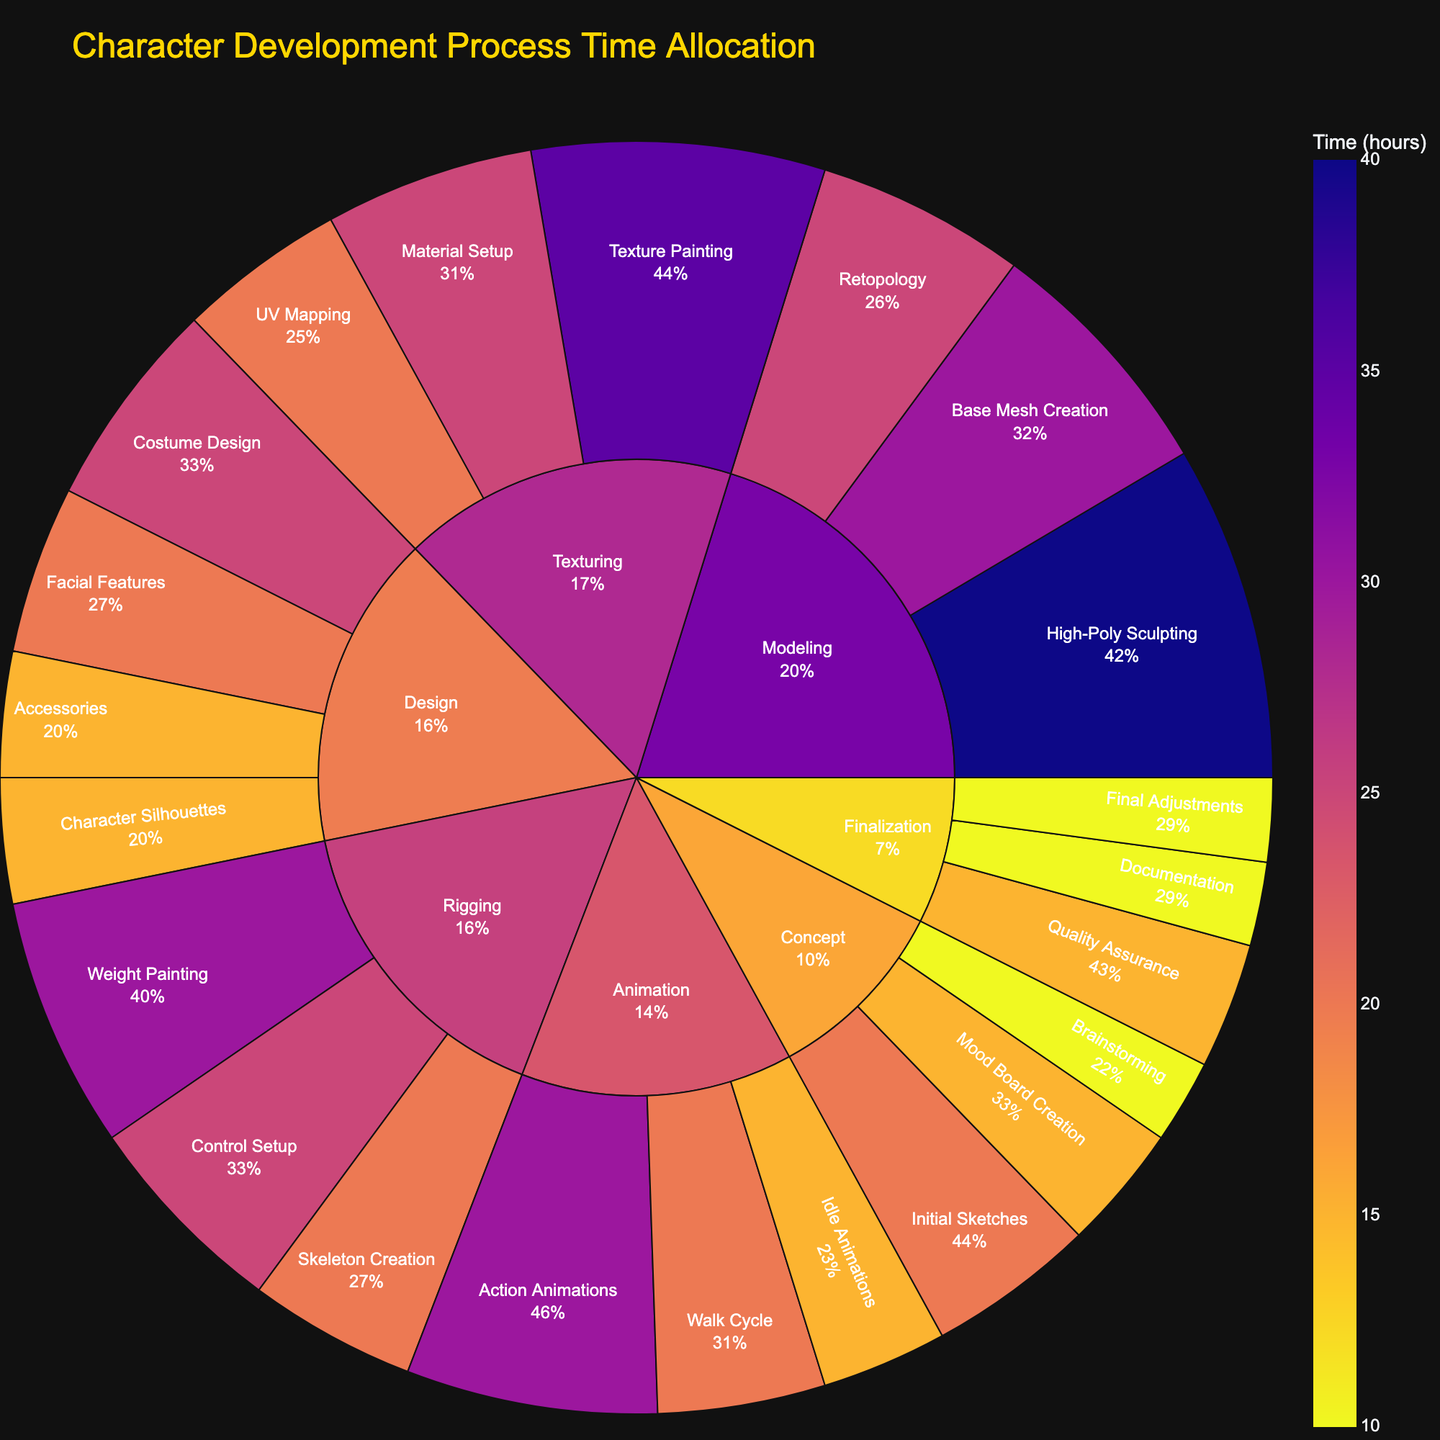What stage of the character development process takes the most time? To determine which stage takes the most time, we need to sum the time spent on each substage within each stage. The stage with the highest total time is the one that takes the most time. Summing the times, we get: Concept (45 hours), Design (75 hours), Modeling (95 hours), Texturing (80 hours), Rigging (75 hours), Animation (65 hours), Finalization (35 hours). Therefore, the stage that takes the most time is Modeling.
Answer: Modeling How much total time is spent on Animation and Finalization combined? To find the total time spent on Animation and Finalization, sum the time spent on each substage within these stages. For Animation: Walk Cycle (20 hours), Idle Animations (15 hours), Action Animations (30 hours), totaling 65 hours. For Finalization: Quality Assurance (15 hours), Final Adjustments (10 hours), Documentation (10 hours), totaling 35 hours. The combined total is 65 + 35 = 100 hours.
Answer: 100 hours Which substage under Design takes the least amount of time? To identify the substage under Design that takes the least time, we compare the time allocated to each substage: Character Silhouettes (15 hours), Facial Features (20 hours), Costume Design (25 hours), Accessories (15 hours). Both Character Silhouettes and Accessories take 15 hours, which is the least time.
Answer: Character Silhouettes and Accessories What percentage of the total time is spent on the Texturing stage? First, calculate the total time spent across all stages by summing the times of all substages: the sum is 445 hours. The time spent on Texturing is the sum of its substages: UV Mapping (20 hours), Texture Painting (35 hours), Material Setup (25 hours), totaling 80 hours. The percentage is (80/445) * 100 ≈ 17.98%.
Answer: Approximately 18% Is more time allocated to Base Mesh Creation in Modeling than to Texture Painting in Texturing? Compare the time allocated to Base Mesh Creation and Texture Painting. Base Mesh Creation has 30 hours, while Texture Painting has 35 hours. Since 30 is less than 35, more time is allocated to Texture Painting.
Answer: No Which stage has a higher time allocation: Design or Rigging? Sum the time for each substage within Design and Rigging. Design: Character Silhouettes (15 hours), Facial Features (20 hours), Costume Design (25 hours), Accessories (15 hours), totaling 75 hours. Rigging: Skeleton Creation (20 hours), Weight Painting (30 hours), Control Setup (25 hours), totaling 75 hours. Both stages have the same total time allocation.
Answer: Same What is the sum of time spent on Concept and any one substage of Animation? Calculate the total time for the Concept stage: Brainstorming (10 hours), Mood Board Creation (15 hours), Initial Sketches (20 hours), totaling 45 hours. Choose one substage of Animation, e.g., Walk Cycle (20 hours). The sum is 45 + 20 = 65 hours.
Answer: 65 hours Which substage of Animation takes the same amount of time as Weight Painting in Rigging? Compare the times of Animation substages with Weight Painting in Rigging. Walk Cycle (20 hours), Idle Animations (15 hours), Action Animations (30 hours), Weight Painting is 30 hours. The substage of Animation that matches 30 hours is Action Animations.
Answer: Action Animations How much more time is spent on High-Poly Sculpting compared to Brainstorming? Determine the time for High-Poly Sculpting (40 hours) and Brainstorming (10 hours). Subtract the time for Brainstorming from that for High-Poly Sculpting: 40 - 10 = 30 hours more for High-Poly Sculpting.
Answer: 30 hours 